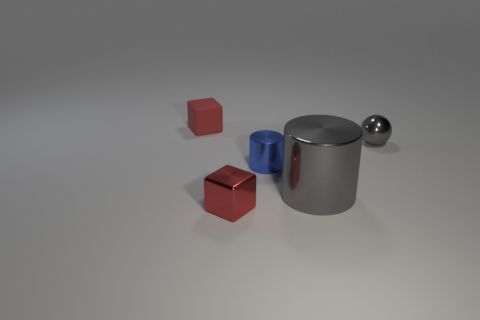Add 5 brown matte spheres. How many objects exist? 10 Subtract all balls. How many objects are left? 4 Add 3 small blue metallic objects. How many small blue metallic objects exist? 4 Subtract 0 cyan balls. How many objects are left? 5 Subtract all red metallic blocks. Subtract all tiny matte cylinders. How many objects are left? 4 Add 2 tiny blue metallic objects. How many tiny blue metallic objects are left? 3 